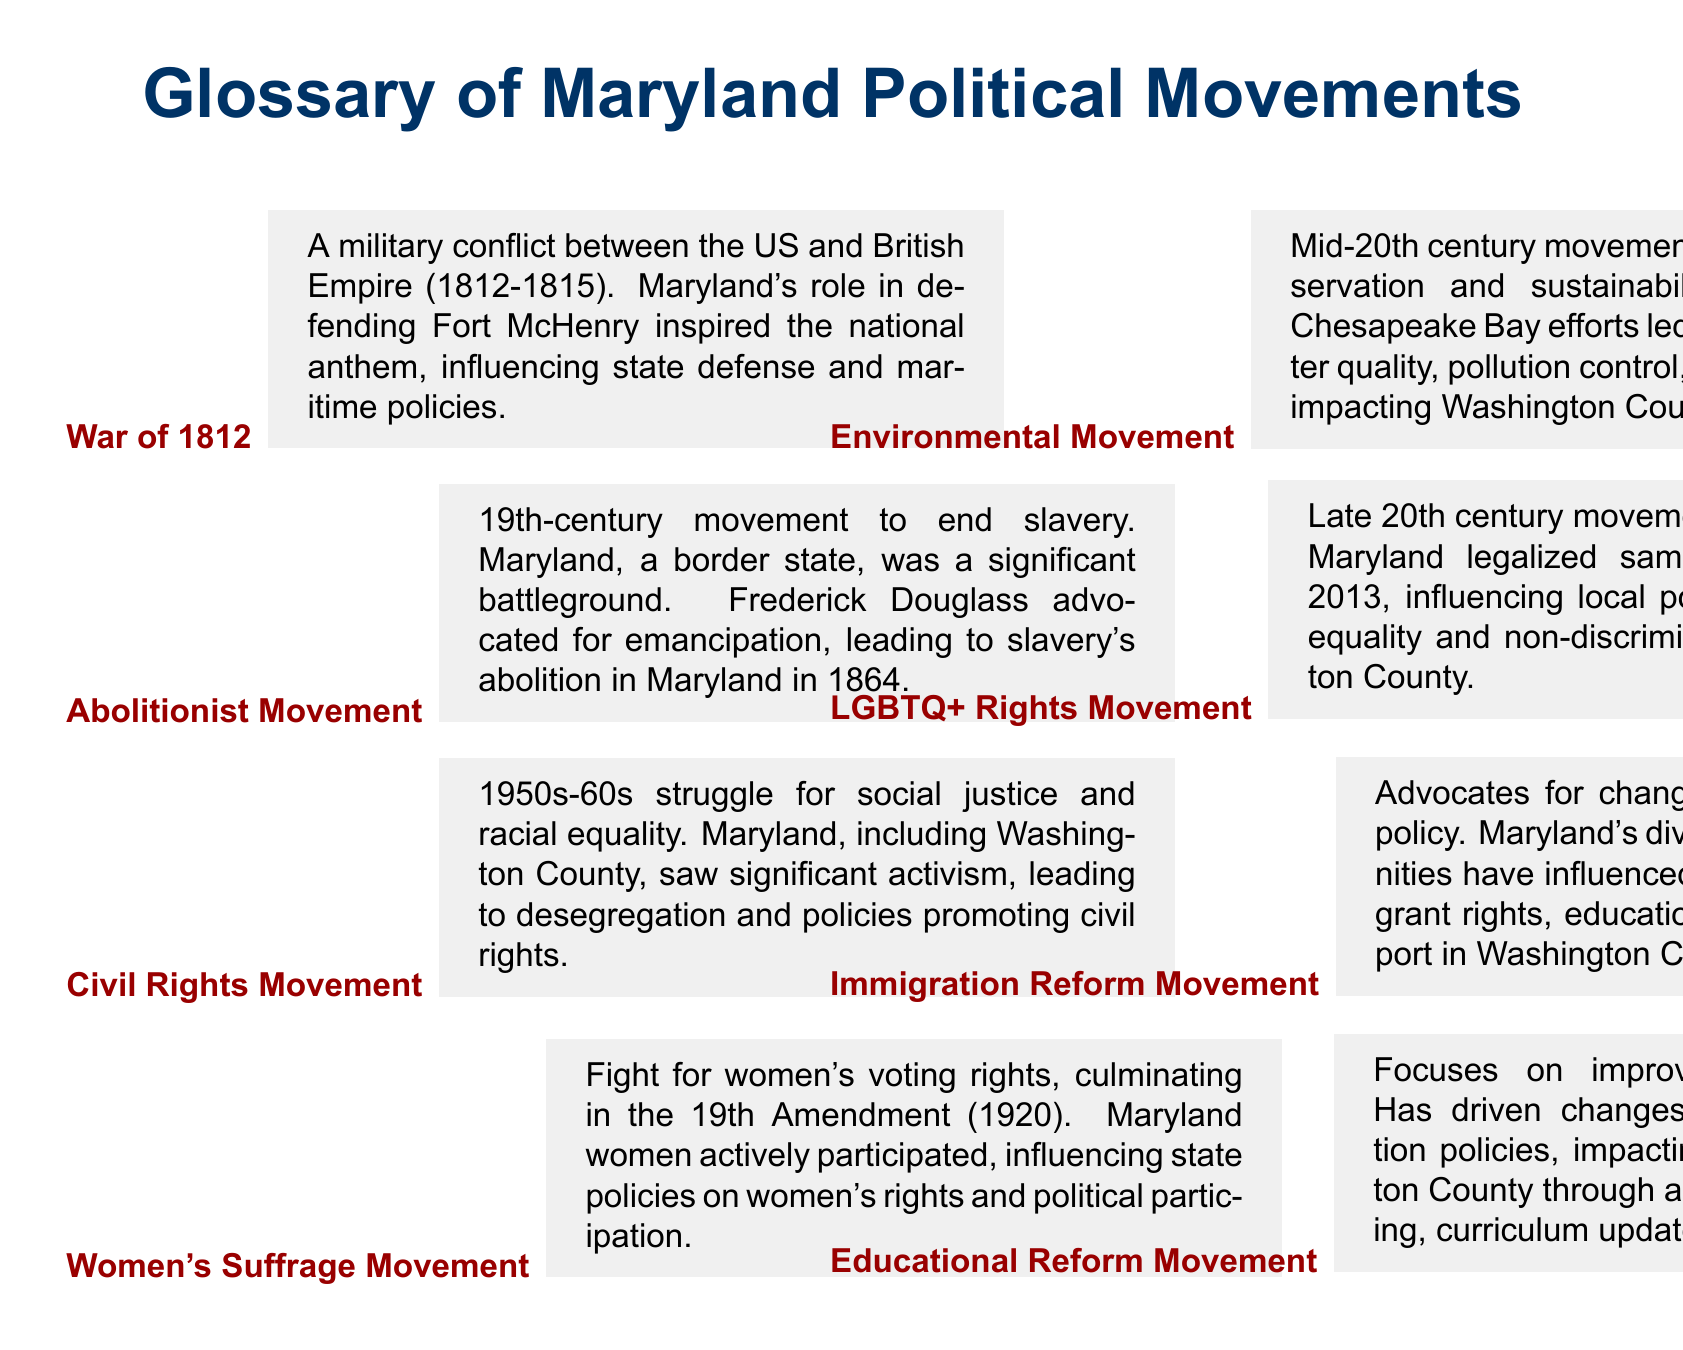what was the role of Maryland in the War of 1812? Maryland defended Fort McHenry during the War of 1812, inspiring the national anthem.
Answer: defending Fort McHenry what landmark legislation resulted from the Women's Suffrage Movement? The Women's Suffrage Movement culminated in the passage of the 19th Amendment, which gave women the right to vote.
Answer: 19th Amendment who was a key advocate in the Abolitionist Movement in Maryland? Frederick Douglass was a significant advocate for emancipation in Maryland.
Answer: Frederick Douglass which movement in Maryland aimed for racial equality in the 1950s and 60s? The Civil Rights Movement in Maryland focused on social justice and racial equality during this period.
Answer: Civil Rights Movement what year did Maryland abolish slavery? Maryland abolished slavery in the year 1864.
Answer: 1864 how did the Environmental Movement affect Washington County? The Environmental Movement led to policies on water quality and pollution control that impacted Washington County.
Answer: water quality and pollution control when was same-sex marriage legalized in Maryland? Same-sex marriage was legalized in Maryland in 2013.
Answer: 2013 what is the focus of the Educational Reform Movement in Maryland? The Educational Reform Movement focuses on improving public education and advocacy for better funding.
Answer: improving public education which political movement significantly influenced local policies on immigrant rights in Washington County? The Immigration Reform Movement advocates for changes to U.S. immigration policy, impacting local policies on immigrant rights.
Answer: Immigration Reform Movement 